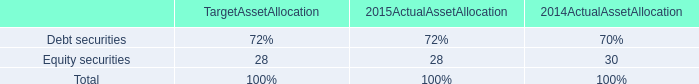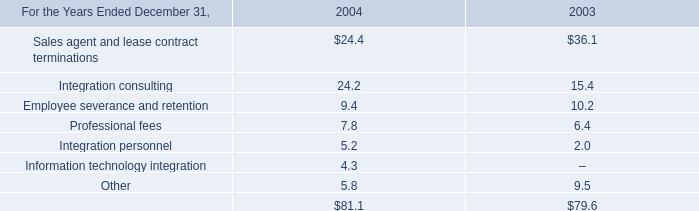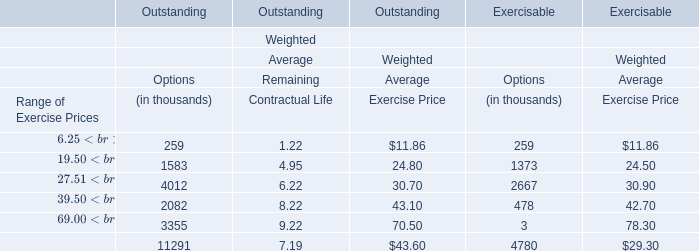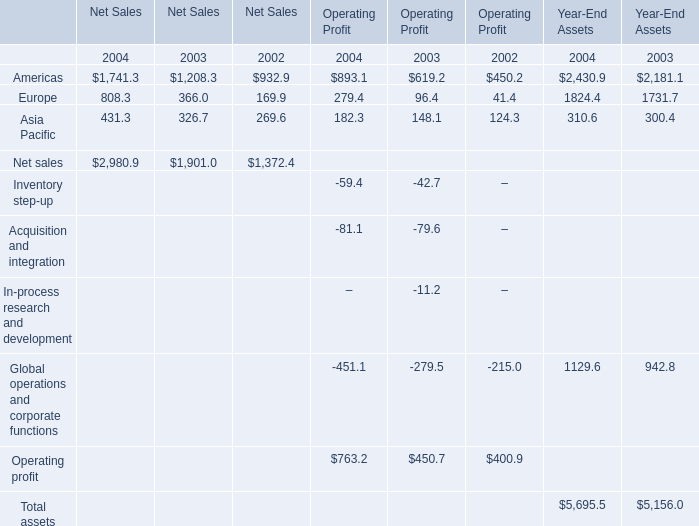What is the Weighted Average Exercise Price for the Range of Exercise Prices $19.50 – $27.50 in terms of Exercisable as As the chart 2 shows? 
Answer: 24.5. 